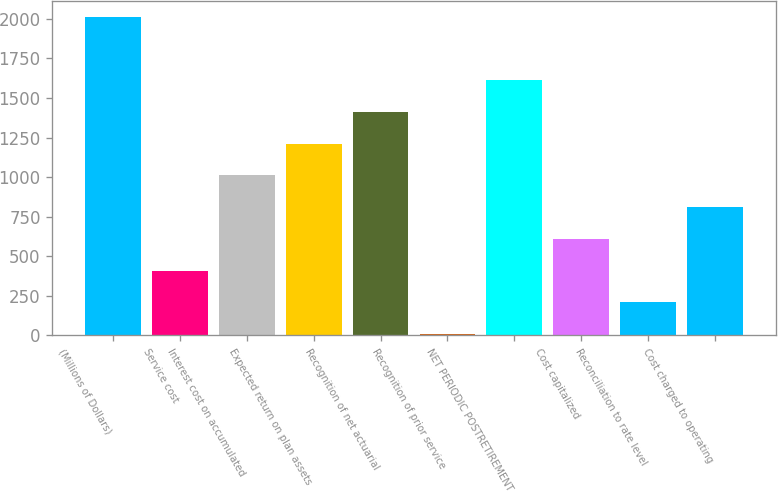Convert chart to OTSL. <chart><loc_0><loc_0><loc_500><loc_500><bar_chart><fcel>(Millions of Dollars)<fcel>Service cost<fcel>Interest cost on accumulated<fcel>Expected return on plan assets<fcel>Recognition of net actuarial<fcel>Recognition of prior service<fcel>NET PERIODIC POSTRETIREMENT<fcel>Cost capitalized<fcel>Reconciliation to rate level<fcel>Cost charged to operating<nl><fcel>2011<fcel>410.2<fcel>1010.5<fcel>1210.6<fcel>1410.7<fcel>10<fcel>1610.8<fcel>610.3<fcel>210.1<fcel>810.4<nl></chart> 